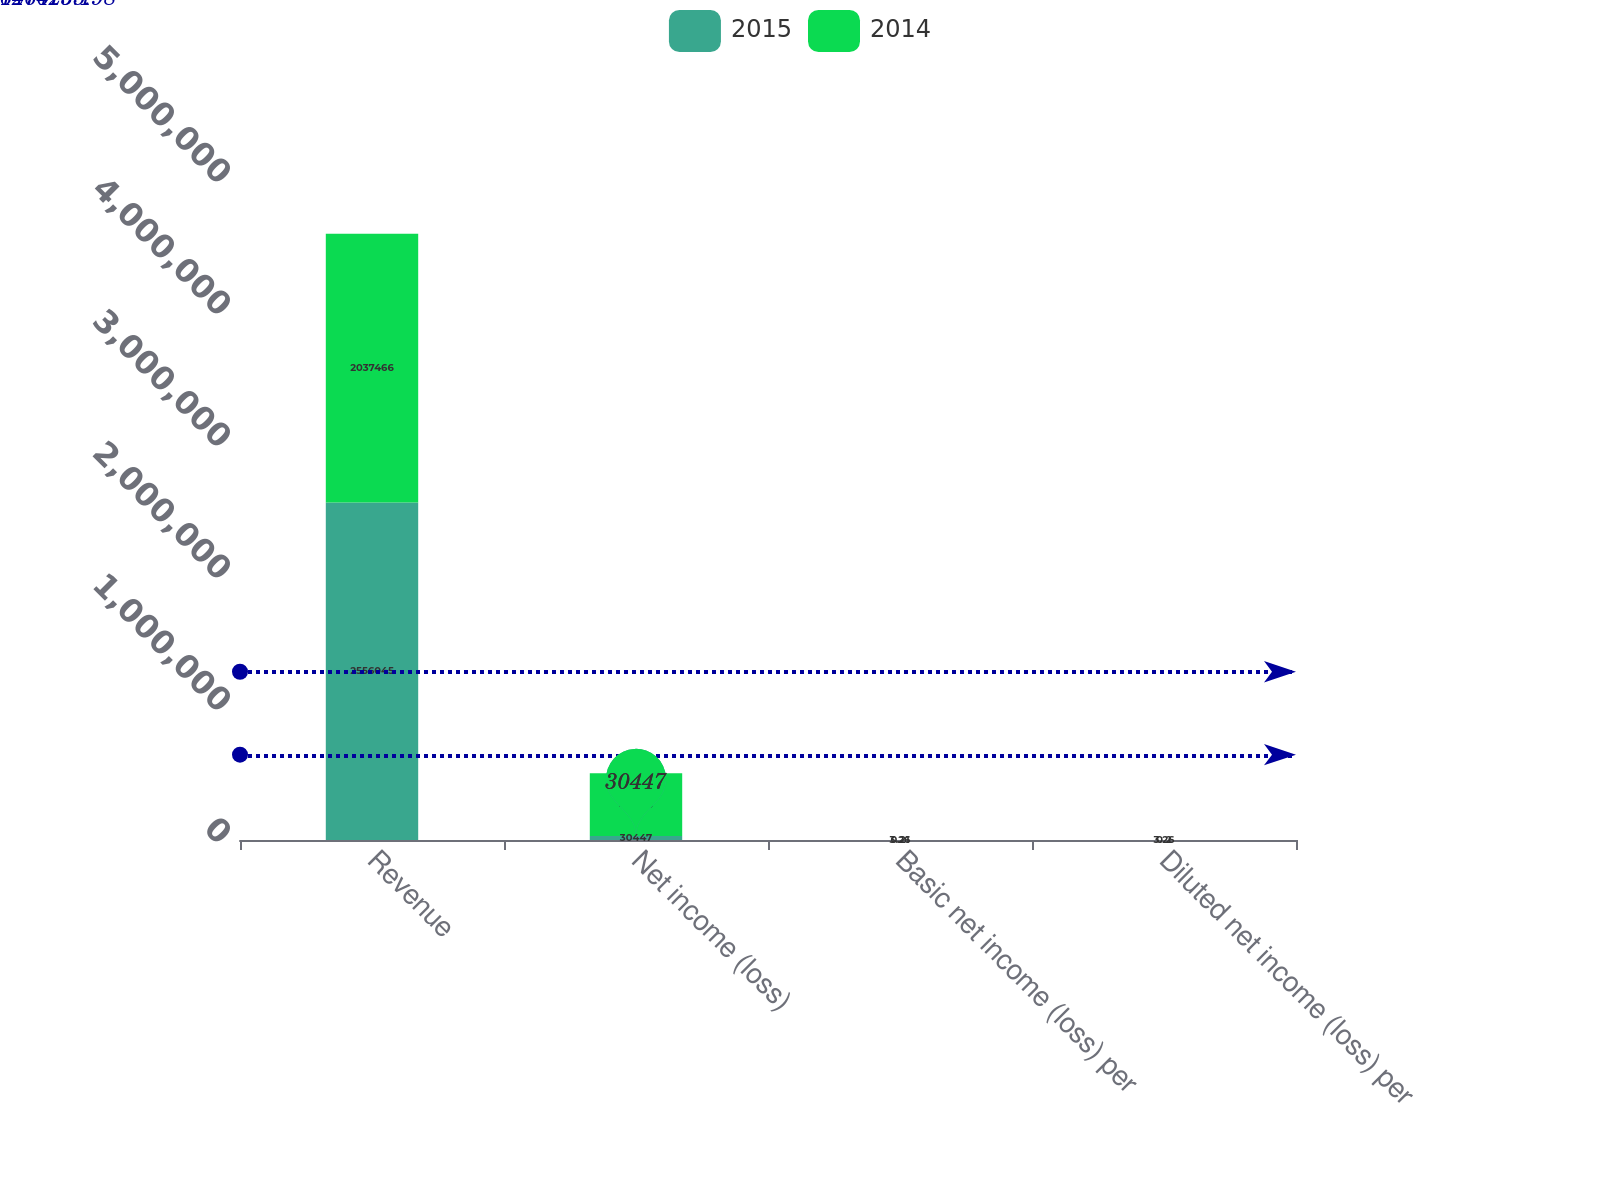Convert chart. <chart><loc_0><loc_0><loc_500><loc_500><stacked_bar_chart><ecel><fcel>Revenue<fcel>Net income (loss)<fcel>Basic net income (loss) per<fcel>Diluted net income (loss) per<nl><fcel>2015<fcel>2.55604e+06<fcel>30447<fcel>0.21<fcel>0.2<nl><fcel>2014<fcel>2.03747e+06<fcel>475219<fcel>3.26<fcel>3.26<nl></chart> 